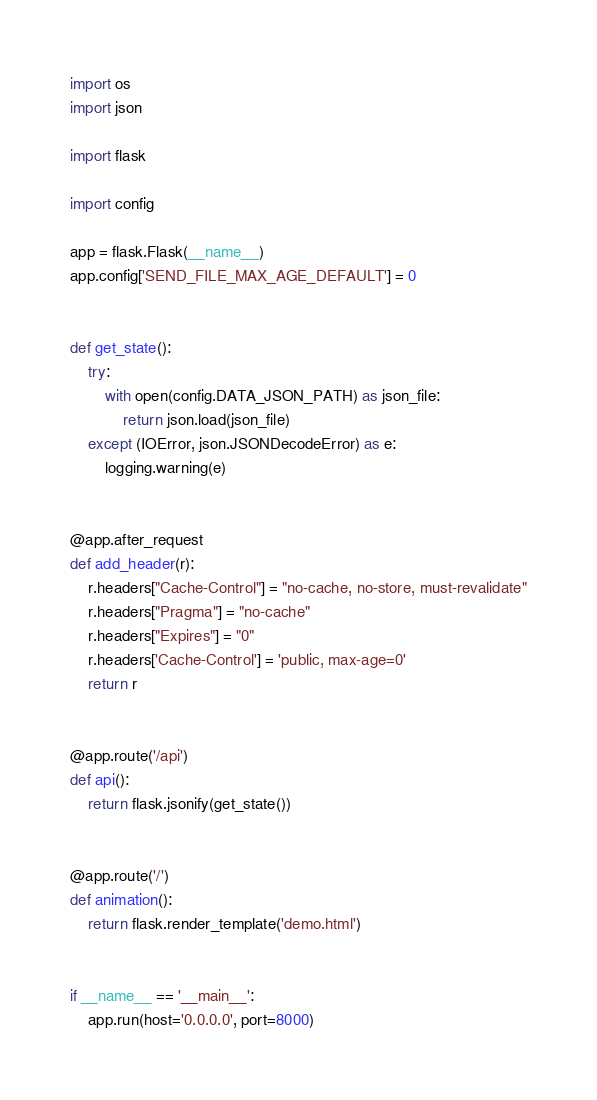Convert code to text. <code><loc_0><loc_0><loc_500><loc_500><_Python_>import os
import json

import flask

import config

app = flask.Flask(__name__)
app.config['SEND_FILE_MAX_AGE_DEFAULT'] = 0


def get_state():
    try:
        with open(config.DATA_JSON_PATH) as json_file:
            return json.load(json_file)
    except (IOError, json.JSONDecodeError) as e:
        logging.warning(e)


@app.after_request
def add_header(r):
    r.headers["Cache-Control"] = "no-cache, no-store, must-revalidate"
    r.headers["Pragma"] = "no-cache"
    r.headers["Expires"] = "0"
    r.headers['Cache-Control'] = 'public, max-age=0'
    return r


@app.route('/api')
def api():
    return flask.jsonify(get_state())


@app.route('/')
def animation():
    return flask.render_template('demo.html')


if __name__ == '__main__':
    app.run(host='0.0.0.0', port=8000)
</code> 